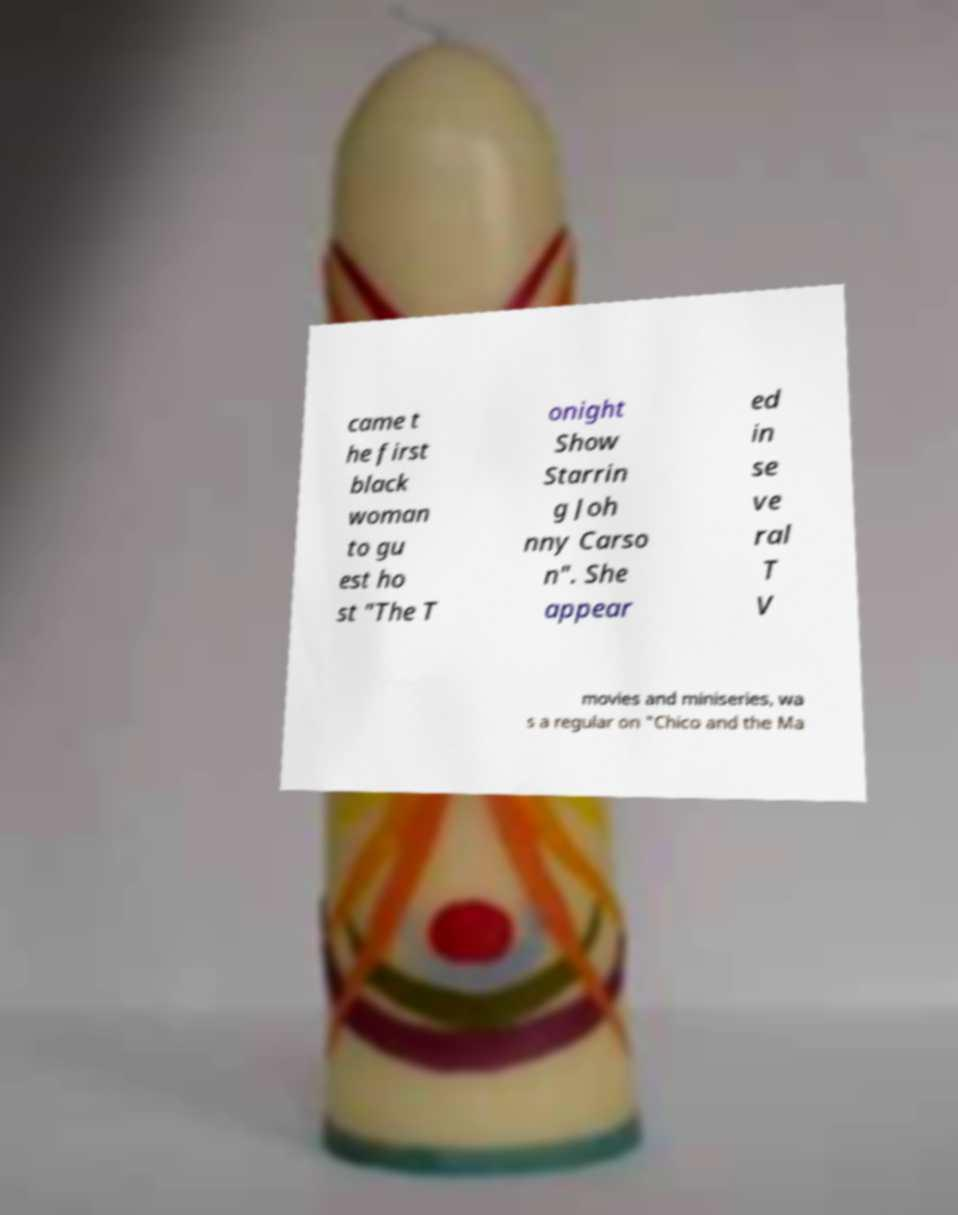Please identify and transcribe the text found in this image. came t he first black woman to gu est ho st "The T onight Show Starrin g Joh nny Carso n". She appear ed in se ve ral T V movies and miniseries, wa s a regular on "Chico and the Ma 